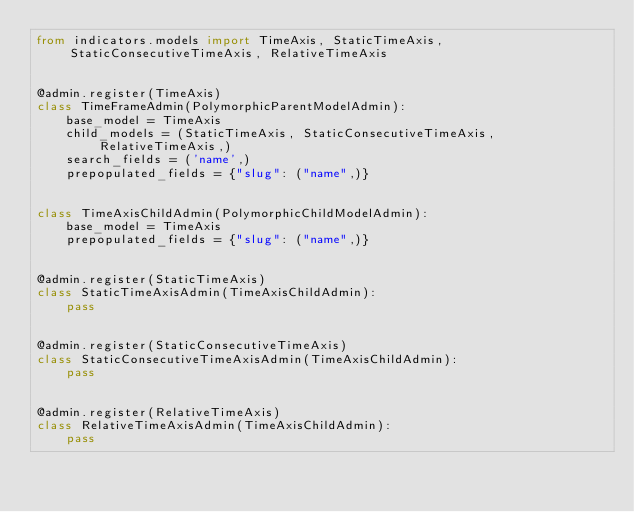Convert code to text. <code><loc_0><loc_0><loc_500><loc_500><_Python_>from indicators.models import TimeAxis, StaticTimeAxis, StaticConsecutiveTimeAxis, RelativeTimeAxis


@admin.register(TimeAxis)
class TimeFrameAdmin(PolymorphicParentModelAdmin):
    base_model = TimeAxis
    child_models = (StaticTimeAxis, StaticConsecutiveTimeAxis, RelativeTimeAxis,)
    search_fields = ('name',)
    prepopulated_fields = {"slug": ("name",)}


class TimeAxisChildAdmin(PolymorphicChildModelAdmin):
    base_model = TimeAxis
    prepopulated_fields = {"slug": ("name",)}


@admin.register(StaticTimeAxis)
class StaticTimeAxisAdmin(TimeAxisChildAdmin):
    pass


@admin.register(StaticConsecutiveTimeAxis)
class StaticConsecutiveTimeAxisAdmin(TimeAxisChildAdmin):
    pass


@admin.register(RelativeTimeAxis)
class RelativeTimeAxisAdmin(TimeAxisChildAdmin):
    pass
</code> 